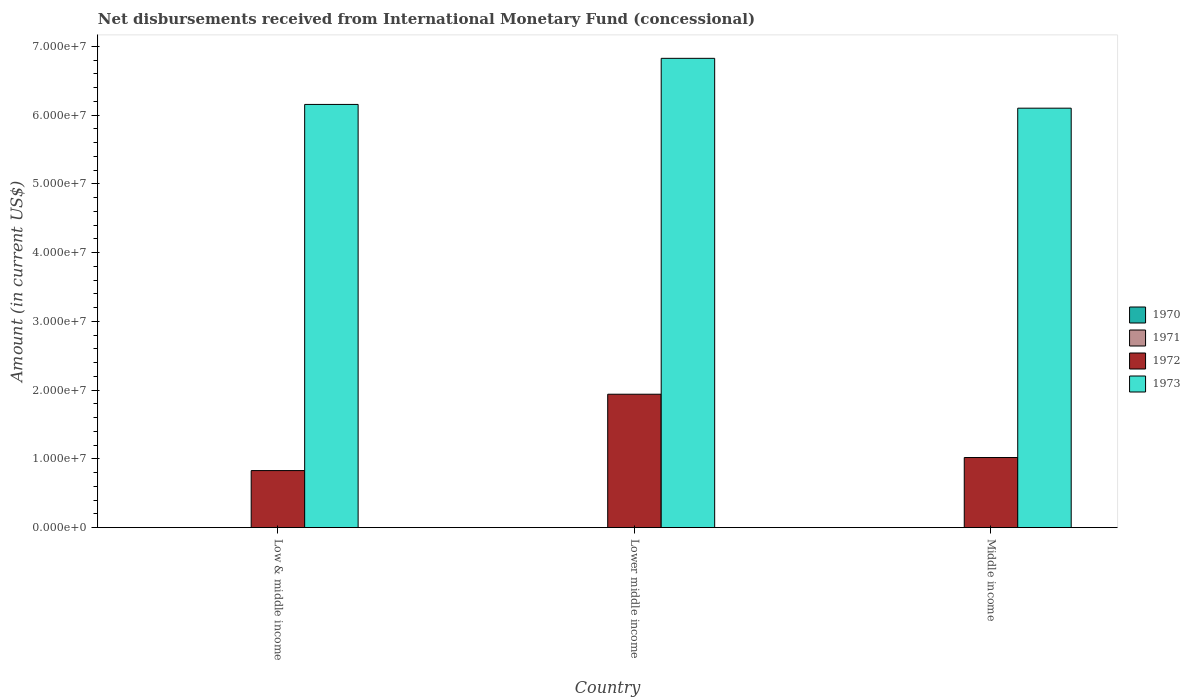Are the number of bars per tick equal to the number of legend labels?
Ensure brevity in your answer.  No. How many bars are there on the 3rd tick from the left?
Provide a succinct answer. 2. What is the amount of disbursements received from International Monetary Fund in 1973 in Low & middle income?
Provide a short and direct response. 6.16e+07. Across all countries, what is the maximum amount of disbursements received from International Monetary Fund in 1973?
Provide a short and direct response. 6.83e+07. In which country was the amount of disbursements received from International Monetary Fund in 1973 maximum?
Give a very brief answer. Lower middle income. What is the total amount of disbursements received from International Monetary Fund in 1972 in the graph?
Offer a very short reply. 3.79e+07. What is the difference between the amount of disbursements received from International Monetary Fund in 1972 in Low & middle income and that in Middle income?
Give a very brief answer. -1.90e+06. What is the difference between the amount of disbursements received from International Monetary Fund in 1971 in Lower middle income and the amount of disbursements received from International Monetary Fund in 1973 in Low & middle income?
Provide a short and direct response. -6.16e+07. What is the average amount of disbursements received from International Monetary Fund in 1971 per country?
Give a very brief answer. 0. In how many countries, is the amount of disbursements received from International Monetary Fund in 1973 greater than 68000000 US$?
Your answer should be compact. 1. What is the ratio of the amount of disbursements received from International Monetary Fund in 1972 in Low & middle income to that in Lower middle income?
Ensure brevity in your answer.  0.43. What is the difference between the highest and the second highest amount of disbursements received from International Monetary Fund in 1973?
Offer a very short reply. -7.25e+06. What is the difference between the highest and the lowest amount of disbursements received from International Monetary Fund in 1973?
Provide a short and direct response. 7.25e+06. In how many countries, is the amount of disbursements received from International Monetary Fund in 1972 greater than the average amount of disbursements received from International Monetary Fund in 1972 taken over all countries?
Offer a terse response. 1. Is the sum of the amount of disbursements received from International Monetary Fund in 1972 in Lower middle income and Middle income greater than the maximum amount of disbursements received from International Monetary Fund in 1971 across all countries?
Keep it short and to the point. Yes. Is it the case that in every country, the sum of the amount of disbursements received from International Monetary Fund in 1973 and amount of disbursements received from International Monetary Fund in 1972 is greater than the amount of disbursements received from International Monetary Fund in 1970?
Your response must be concise. Yes. How many bars are there?
Your answer should be compact. 6. Are all the bars in the graph horizontal?
Give a very brief answer. No. How many countries are there in the graph?
Your response must be concise. 3. Are the values on the major ticks of Y-axis written in scientific E-notation?
Your answer should be compact. Yes. Does the graph contain any zero values?
Your answer should be compact. Yes. How are the legend labels stacked?
Ensure brevity in your answer.  Vertical. What is the title of the graph?
Give a very brief answer. Net disbursements received from International Monetary Fund (concessional). What is the label or title of the X-axis?
Give a very brief answer. Country. What is the Amount (in current US$) in 1970 in Low & middle income?
Offer a very short reply. 0. What is the Amount (in current US$) in 1971 in Low & middle income?
Give a very brief answer. 0. What is the Amount (in current US$) in 1972 in Low & middle income?
Give a very brief answer. 8.30e+06. What is the Amount (in current US$) in 1973 in Low & middle income?
Make the answer very short. 6.16e+07. What is the Amount (in current US$) of 1970 in Lower middle income?
Offer a terse response. 0. What is the Amount (in current US$) in 1972 in Lower middle income?
Provide a short and direct response. 1.94e+07. What is the Amount (in current US$) in 1973 in Lower middle income?
Give a very brief answer. 6.83e+07. What is the Amount (in current US$) of 1970 in Middle income?
Provide a succinct answer. 0. What is the Amount (in current US$) in 1972 in Middle income?
Offer a terse response. 1.02e+07. What is the Amount (in current US$) of 1973 in Middle income?
Your response must be concise. 6.10e+07. Across all countries, what is the maximum Amount (in current US$) in 1972?
Keep it short and to the point. 1.94e+07. Across all countries, what is the maximum Amount (in current US$) in 1973?
Provide a short and direct response. 6.83e+07. Across all countries, what is the minimum Amount (in current US$) of 1972?
Your answer should be very brief. 8.30e+06. Across all countries, what is the minimum Amount (in current US$) of 1973?
Your answer should be very brief. 6.10e+07. What is the total Amount (in current US$) in 1972 in the graph?
Your response must be concise. 3.79e+07. What is the total Amount (in current US$) of 1973 in the graph?
Provide a short and direct response. 1.91e+08. What is the difference between the Amount (in current US$) of 1972 in Low & middle income and that in Lower middle income?
Your answer should be very brief. -1.11e+07. What is the difference between the Amount (in current US$) in 1973 in Low & middle income and that in Lower middle income?
Give a very brief answer. -6.70e+06. What is the difference between the Amount (in current US$) of 1972 in Low & middle income and that in Middle income?
Provide a short and direct response. -1.90e+06. What is the difference between the Amount (in current US$) of 1973 in Low & middle income and that in Middle income?
Your response must be concise. 5.46e+05. What is the difference between the Amount (in current US$) of 1972 in Lower middle income and that in Middle income?
Your answer should be very brief. 9.21e+06. What is the difference between the Amount (in current US$) in 1973 in Lower middle income and that in Middle income?
Provide a succinct answer. 7.25e+06. What is the difference between the Amount (in current US$) of 1972 in Low & middle income and the Amount (in current US$) of 1973 in Lower middle income?
Give a very brief answer. -6.00e+07. What is the difference between the Amount (in current US$) of 1972 in Low & middle income and the Amount (in current US$) of 1973 in Middle income?
Ensure brevity in your answer.  -5.27e+07. What is the difference between the Amount (in current US$) in 1972 in Lower middle income and the Amount (in current US$) in 1973 in Middle income?
Keep it short and to the point. -4.16e+07. What is the average Amount (in current US$) of 1970 per country?
Offer a very short reply. 0. What is the average Amount (in current US$) of 1971 per country?
Your answer should be very brief. 0. What is the average Amount (in current US$) of 1972 per country?
Offer a terse response. 1.26e+07. What is the average Amount (in current US$) of 1973 per country?
Your answer should be compact. 6.36e+07. What is the difference between the Amount (in current US$) in 1972 and Amount (in current US$) in 1973 in Low & middle income?
Give a very brief answer. -5.33e+07. What is the difference between the Amount (in current US$) of 1972 and Amount (in current US$) of 1973 in Lower middle income?
Make the answer very short. -4.89e+07. What is the difference between the Amount (in current US$) in 1972 and Amount (in current US$) in 1973 in Middle income?
Offer a very short reply. -5.08e+07. What is the ratio of the Amount (in current US$) in 1972 in Low & middle income to that in Lower middle income?
Offer a terse response. 0.43. What is the ratio of the Amount (in current US$) in 1973 in Low & middle income to that in Lower middle income?
Offer a very short reply. 0.9. What is the ratio of the Amount (in current US$) of 1972 in Low & middle income to that in Middle income?
Ensure brevity in your answer.  0.81. What is the ratio of the Amount (in current US$) of 1973 in Low & middle income to that in Middle income?
Offer a terse response. 1.01. What is the ratio of the Amount (in current US$) of 1972 in Lower middle income to that in Middle income?
Provide a short and direct response. 1.9. What is the ratio of the Amount (in current US$) in 1973 in Lower middle income to that in Middle income?
Offer a very short reply. 1.12. What is the difference between the highest and the second highest Amount (in current US$) of 1972?
Keep it short and to the point. 9.21e+06. What is the difference between the highest and the second highest Amount (in current US$) of 1973?
Provide a succinct answer. 6.70e+06. What is the difference between the highest and the lowest Amount (in current US$) in 1972?
Ensure brevity in your answer.  1.11e+07. What is the difference between the highest and the lowest Amount (in current US$) of 1973?
Make the answer very short. 7.25e+06. 